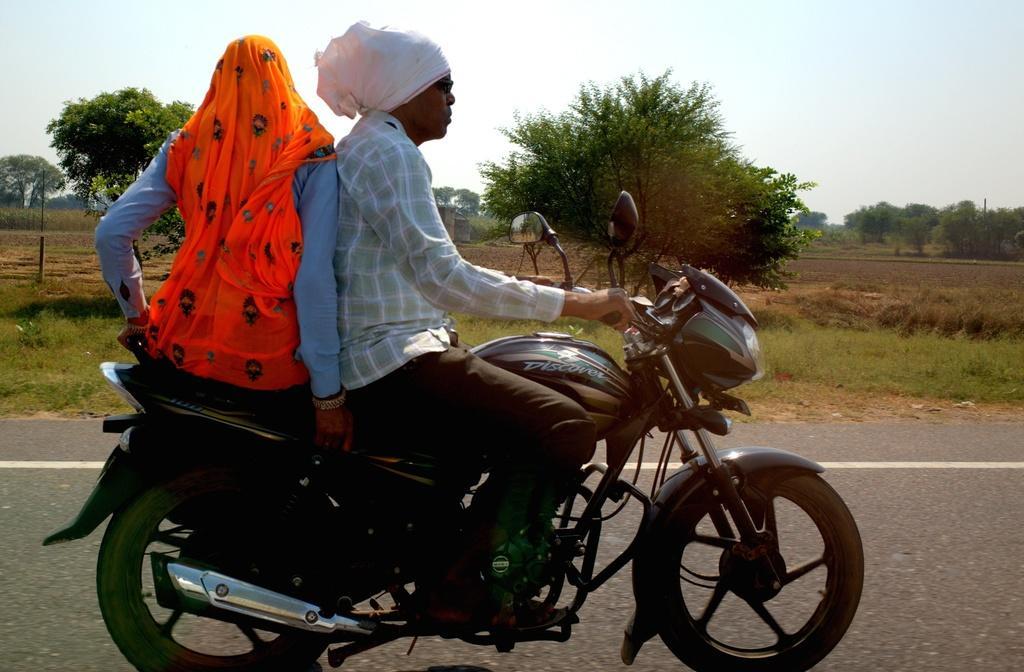Please provide a concise description of this image. In the picture, there is a man and a man and woman are travelling on the bike behind them there is a grass,some trees and a sky. 